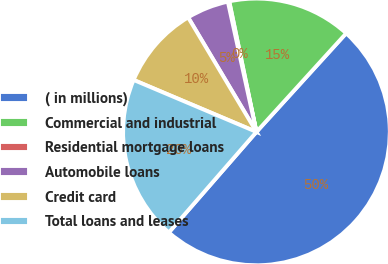Convert chart. <chart><loc_0><loc_0><loc_500><loc_500><pie_chart><fcel>( in millions)<fcel>Commercial and industrial<fcel>Residential mortgage loans<fcel>Automobile loans<fcel>Credit card<fcel>Total loans and leases<nl><fcel>49.66%<fcel>15.02%<fcel>0.17%<fcel>5.12%<fcel>10.07%<fcel>19.97%<nl></chart> 